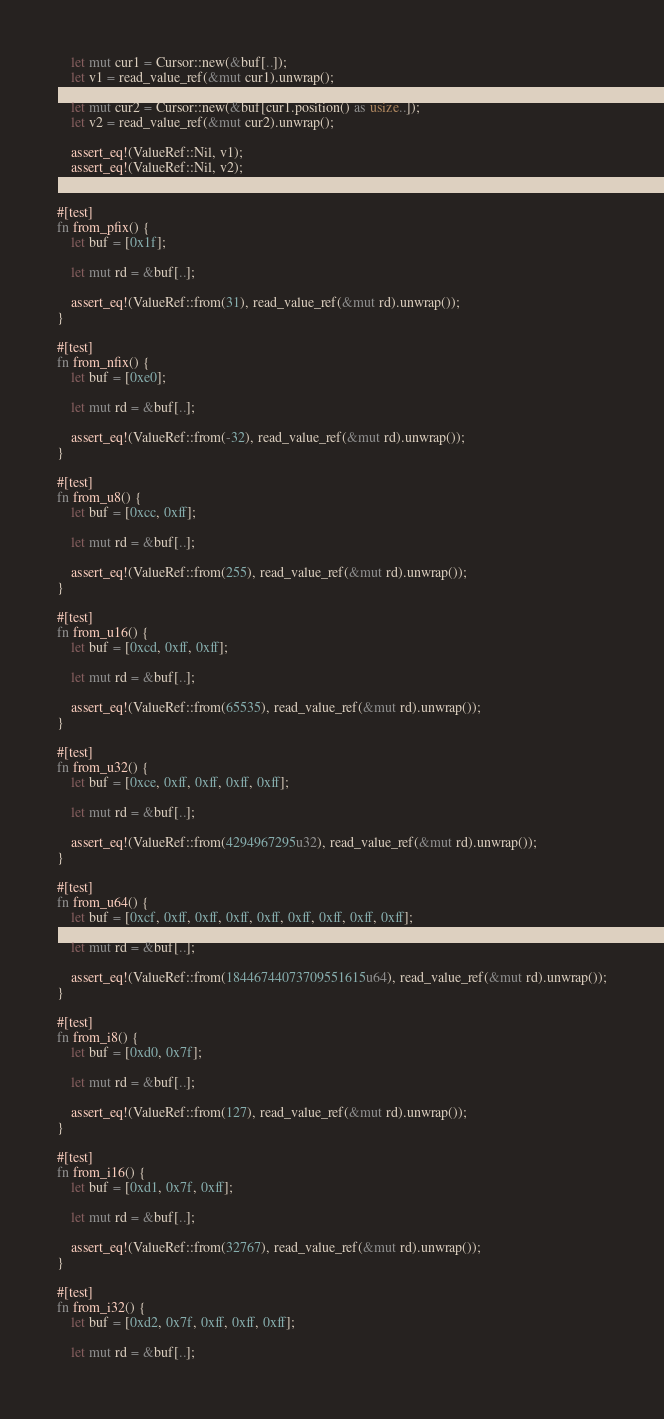Convert code to text. <code><loc_0><loc_0><loc_500><loc_500><_Rust_>
    let mut cur1 = Cursor::new(&buf[..]);
    let v1 = read_value_ref(&mut cur1).unwrap();

    let mut cur2 = Cursor::new(&buf[cur1.position() as usize..]);
    let v2 = read_value_ref(&mut cur2).unwrap();

    assert_eq!(ValueRef::Nil, v1);
    assert_eq!(ValueRef::Nil, v2);
}

#[test]
fn from_pfix() {
    let buf = [0x1f];

    let mut rd = &buf[..];

    assert_eq!(ValueRef::from(31), read_value_ref(&mut rd).unwrap());
}

#[test]
fn from_nfix() {
    let buf = [0xe0];

    let mut rd = &buf[..];

    assert_eq!(ValueRef::from(-32), read_value_ref(&mut rd).unwrap());
}

#[test]
fn from_u8() {
    let buf = [0xcc, 0xff];

    let mut rd = &buf[..];

    assert_eq!(ValueRef::from(255), read_value_ref(&mut rd).unwrap());
}

#[test]
fn from_u16() {
    let buf = [0xcd, 0xff, 0xff];

    let mut rd = &buf[..];

    assert_eq!(ValueRef::from(65535), read_value_ref(&mut rd).unwrap());
}

#[test]
fn from_u32() {
    let buf = [0xce, 0xff, 0xff, 0xff, 0xff];

    let mut rd = &buf[..];

    assert_eq!(ValueRef::from(4294967295u32), read_value_ref(&mut rd).unwrap());
}

#[test]
fn from_u64() {
    let buf = [0xcf, 0xff, 0xff, 0xff, 0xff, 0xff, 0xff, 0xff, 0xff];

    let mut rd = &buf[..];

    assert_eq!(ValueRef::from(18446744073709551615u64), read_value_ref(&mut rd).unwrap());
}

#[test]
fn from_i8() {
    let buf = [0xd0, 0x7f];

    let mut rd = &buf[..];

    assert_eq!(ValueRef::from(127), read_value_ref(&mut rd).unwrap());
}

#[test]
fn from_i16() {
    let buf = [0xd1, 0x7f, 0xff];

    let mut rd = &buf[..];

    assert_eq!(ValueRef::from(32767), read_value_ref(&mut rd).unwrap());
}

#[test]
fn from_i32() {
    let buf = [0xd2, 0x7f, 0xff, 0xff, 0xff];

    let mut rd = &buf[..];
</code> 